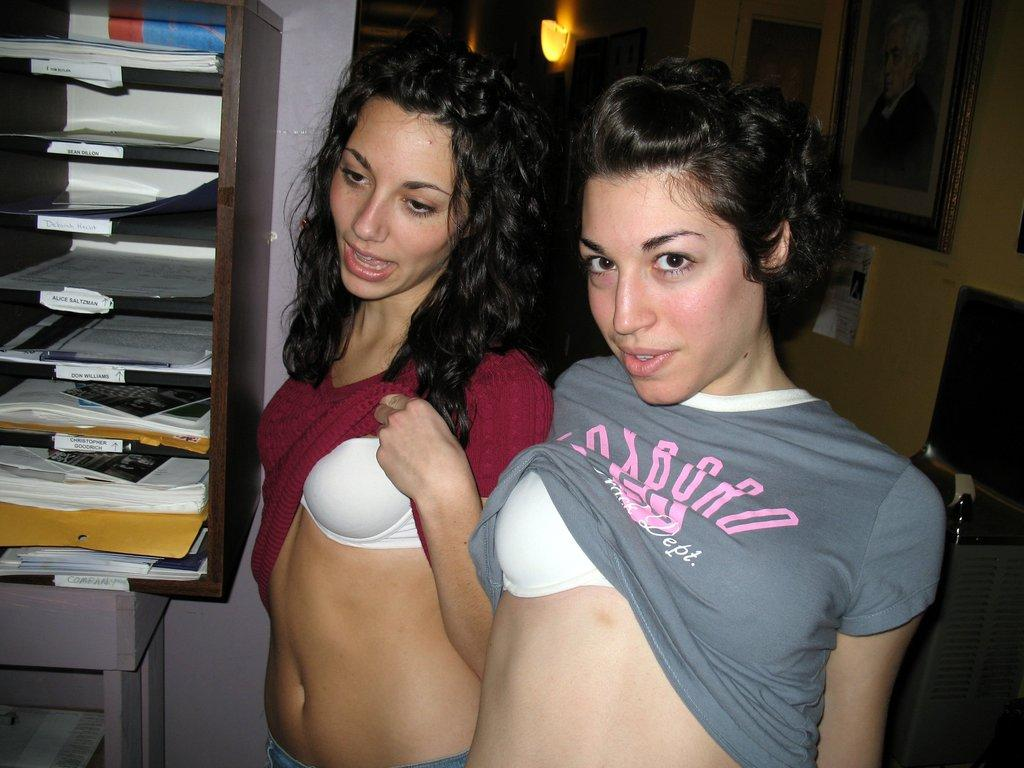Provide a one-sentence caption for the provided image. Two ladies pulling up the shirts in an office with one shirt daying Track dept. 